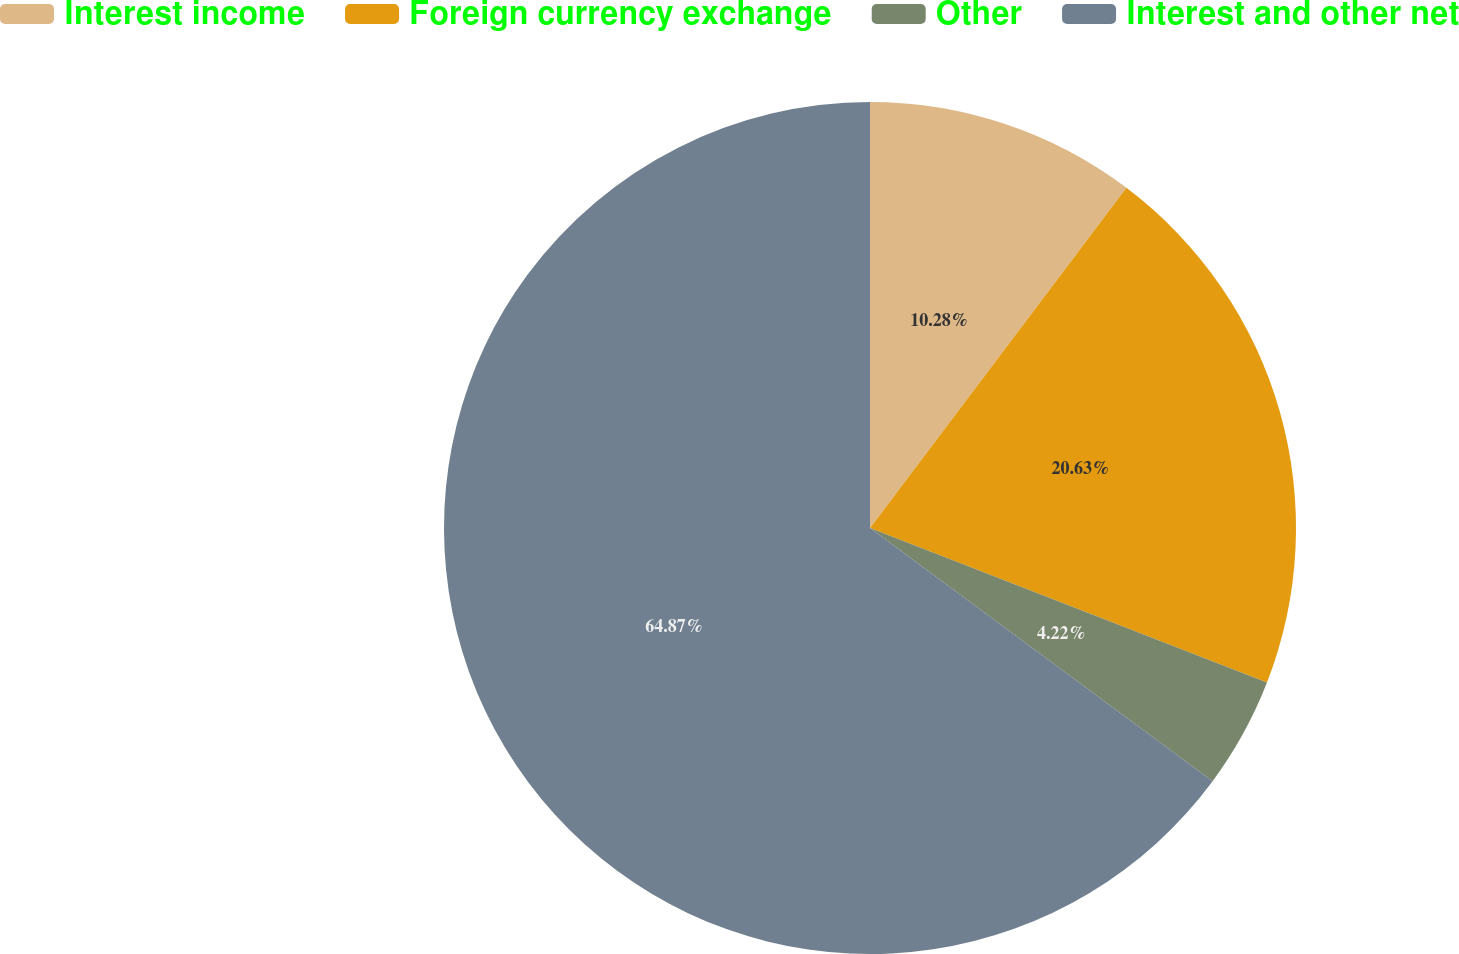<chart> <loc_0><loc_0><loc_500><loc_500><pie_chart><fcel>Interest income<fcel>Foreign currency exchange<fcel>Other<fcel>Interest and other net<nl><fcel>10.28%<fcel>20.63%<fcel>4.22%<fcel>64.87%<nl></chart> 